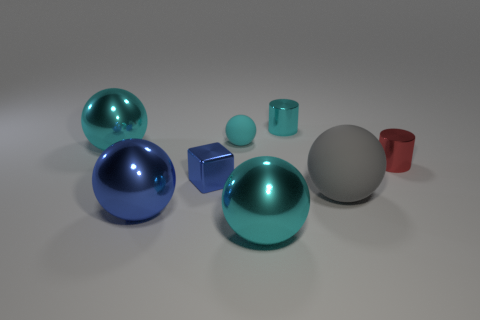Do the small sphere and the large cyan thing that is in front of the big rubber thing have the same material? Based on the image, the small sphere and the large cyan object in front of the big rubber item appear to have different finishes and reflections, which suggests they are made of different materials. The small sphere exhibits a shinier surface with sharper reflections, typical of a smooth, possibly metallic material, whereas the large cyan object has a more diffused reflection, indicating a possibly more matte or plastic-like material. 